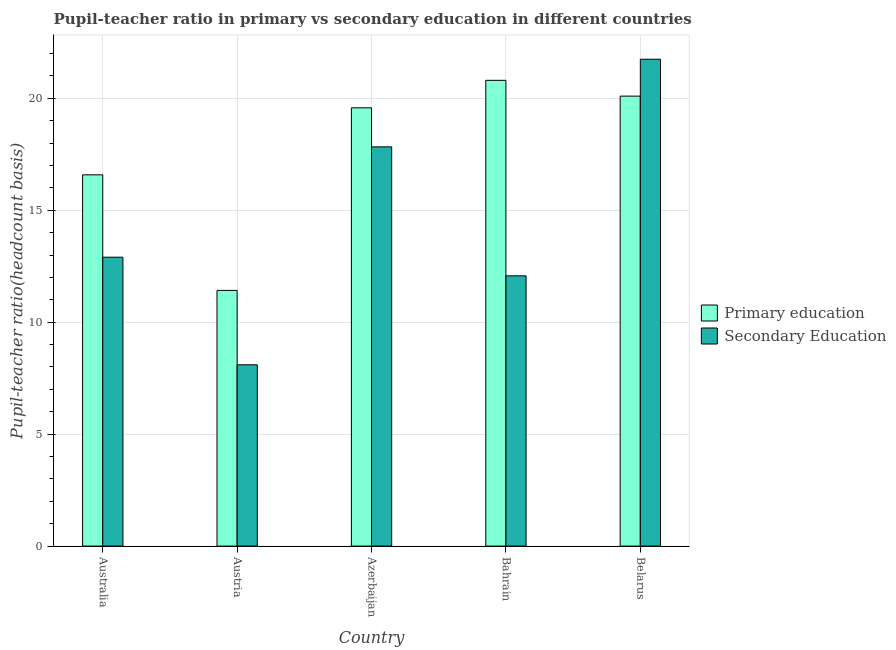Are the number of bars on each tick of the X-axis equal?
Your answer should be compact. Yes. In how many cases, is the number of bars for a given country not equal to the number of legend labels?
Your response must be concise. 0. What is the pupil-teacher ratio in primary education in Australia?
Offer a very short reply. 16.58. Across all countries, what is the maximum pupil teacher ratio on secondary education?
Your answer should be very brief. 21.75. Across all countries, what is the minimum pupil-teacher ratio in primary education?
Offer a terse response. 11.42. In which country was the pupil teacher ratio on secondary education maximum?
Your response must be concise. Belarus. In which country was the pupil-teacher ratio in primary education minimum?
Offer a very short reply. Austria. What is the total pupil teacher ratio on secondary education in the graph?
Make the answer very short. 72.65. What is the difference between the pupil-teacher ratio in primary education in Australia and that in Bahrain?
Your answer should be very brief. -4.22. What is the difference between the pupil teacher ratio on secondary education in Bahrain and the pupil-teacher ratio in primary education in Belarus?
Offer a terse response. -8.03. What is the average pupil-teacher ratio in primary education per country?
Make the answer very short. 17.7. What is the difference between the pupil teacher ratio on secondary education and pupil-teacher ratio in primary education in Azerbaijan?
Give a very brief answer. -1.74. What is the ratio of the pupil-teacher ratio in primary education in Australia to that in Belarus?
Offer a terse response. 0.83. Is the pupil teacher ratio on secondary education in Azerbaijan less than that in Belarus?
Make the answer very short. Yes. What is the difference between the highest and the second highest pupil-teacher ratio in primary education?
Your response must be concise. 0.7. What is the difference between the highest and the lowest pupil-teacher ratio in primary education?
Your answer should be very brief. 9.38. What does the 1st bar from the left in Belarus represents?
Ensure brevity in your answer.  Primary education. How many bars are there?
Provide a succinct answer. 10. Are all the bars in the graph horizontal?
Ensure brevity in your answer.  No. How many countries are there in the graph?
Provide a short and direct response. 5. What is the difference between two consecutive major ticks on the Y-axis?
Ensure brevity in your answer.  5. Does the graph contain grids?
Provide a succinct answer. Yes. How many legend labels are there?
Ensure brevity in your answer.  2. How are the legend labels stacked?
Your answer should be very brief. Vertical. What is the title of the graph?
Make the answer very short. Pupil-teacher ratio in primary vs secondary education in different countries. What is the label or title of the X-axis?
Ensure brevity in your answer.  Country. What is the label or title of the Y-axis?
Ensure brevity in your answer.  Pupil-teacher ratio(headcount basis). What is the Pupil-teacher ratio(headcount basis) of Primary education in Australia?
Ensure brevity in your answer.  16.58. What is the Pupil-teacher ratio(headcount basis) of Secondary Education in Australia?
Your answer should be compact. 12.9. What is the Pupil-teacher ratio(headcount basis) in Primary education in Austria?
Give a very brief answer. 11.42. What is the Pupil-teacher ratio(headcount basis) of Secondary Education in Austria?
Offer a terse response. 8.1. What is the Pupil-teacher ratio(headcount basis) of Primary education in Azerbaijan?
Keep it short and to the point. 19.58. What is the Pupil-teacher ratio(headcount basis) in Secondary Education in Azerbaijan?
Provide a short and direct response. 17.83. What is the Pupil-teacher ratio(headcount basis) in Primary education in Bahrain?
Offer a very short reply. 20.8. What is the Pupil-teacher ratio(headcount basis) of Secondary Education in Bahrain?
Provide a short and direct response. 12.07. What is the Pupil-teacher ratio(headcount basis) of Primary education in Belarus?
Provide a succinct answer. 20.1. What is the Pupil-teacher ratio(headcount basis) in Secondary Education in Belarus?
Provide a short and direct response. 21.75. Across all countries, what is the maximum Pupil-teacher ratio(headcount basis) in Primary education?
Provide a short and direct response. 20.8. Across all countries, what is the maximum Pupil-teacher ratio(headcount basis) of Secondary Education?
Your answer should be very brief. 21.75. Across all countries, what is the minimum Pupil-teacher ratio(headcount basis) of Primary education?
Offer a terse response. 11.42. Across all countries, what is the minimum Pupil-teacher ratio(headcount basis) of Secondary Education?
Your response must be concise. 8.1. What is the total Pupil-teacher ratio(headcount basis) of Primary education in the graph?
Provide a short and direct response. 88.48. What is the total Pupil-teacher ratio(headcount basis) in Secondary Education in the graph?
Give a very brief answer. 72.65. What is the difference between the Pupil-teacher ratio(headcount basis) of Primary education in Australia and that in Austria?
Provide a short and direct response. 5.16. What is the difference between the Pupil-teacher ratio(headcount basis) in Secondary Education in Australia and that in Austria?
Ensure brevity in your answer.  4.8. What is the difference between the Pupil-teacher ratio(headcount basis) in Primary education in Australia and that in Azerbaijan?
Keep it short and to the point. -2.99. What is the difference between the Pupil-teacher ratio(headcount basis) in Secondary Education in Australia and that in Azerbaijan?
Give a very brief answer. -4.93. What is the difference between the Pupil-teacher ratio(headcount basis) of Primary education in Australia and that in Bahrain?
Make the answer very short. -4.22. What is the difference between the Pupil-teacher ratio(headcount basis) of Secondary Education in Australia and that in Bahrain?
Offer a terse response. 0.83. What is the difference between the Pupil-teacher ratio(headcount basis) in Primary education in Australia and that in Belarus?
Provide a succinct answer. -3.52. What is the difference between the Pupil-teacher ratio(headcount basis) of Secondary Education in Australia and that in Belarus?
Your answer should be compact. -8.84. What is the difference between the Pupil-teacher ratio(headcount basis) of Primary education in Austria and that in Azerbaijan?
Your answer should be very brief. -8.16. What is the difference between the Pupil-teacher ratio(headcount basis) in Secondary Education in Austria and that in Azerbaijan?
Make the answer very short. -9.73. What is the difference between the Pupil-teacher ratio(headcount basis) of Primary education in Austria and that in Bahrain?
Your answer should be very brief. -9.38. What is the difference between the Pupil-teacher ratio(headcount basis) of Secondary Education in Austria and that in Bahrain?
Your answer should be very brief. -3.97. What is the difference between the Pupil-teacher ratio(headcount basis) of Primary education in Austria and that in Belarus?
Give a very brief answer. -8.68. What is the difference between the Pupil-teacher ratio(headcount basis) in Secondary Education in Austria and that in Belarus?
Provide a succinct answer. -13.65. What is the difference between the Pupil-teacher ratio(headcount basis) of Primary education in Azerbaijan and that in Bahrain?
Your answer should be very brief. -1.23. What is the difference between the Pupil-teacher ratio(headcount basis) of Secondary Education in Azerbaijan and that in Bahrain?
Ensure brevity in your answer.  5.76. What is the difference between the Pupil-teacher ratio(headcount basis) in Primary education in Azerbaijan and that in Belarus?
Offer a terse response. -0.52. What is the difference between the Pupil-teacher ratio(headcount basis) in Secondary Education in Azerbaijan and that in Belarus?
Offer a very short reply. -3.91. What is the difference between the Pupil-teacher ratio(headcount basis) in Primary education in Bahrain and that in Belarus?
Provide a short and direct response. 0.7. What is the difference between the Pupil-teacher ratio(headcount basis) of Secondary Education in Bahrain and that in Belarus?
Your response must be concise. -9.67. What is the difference between the Pupil-teacher ratio(headcount basis) in Primary education in Australia and the Pupil-teacher ratio(headcount basis) in Secondary Education in Austria?
Offer a very short reply. 8.48. What is the difference between the Pupil-teacher ratio(headcount basis) in Primary education in Australia and the Pupil-teacher ratio(headcount basis) in Secondary Education in Azerbaijan?
Ensure brevity in your answer.  -1.25. What is the difference between the Pupil-teacher ratio(headcount basis) in Primary education in Australia and the Pupil-teacher ratio(headcount basis) in Secondary Education in Bahrain?
Ensure brevity in your answer.  4.51. What is the difference between the Pupil-teacher ratio(headcount basis) of Primary education in Australia and the Pupil-teacher ratio(headcount basis) of Secondary Education in Belarus?
Give a very brief answer. -5.16. What is the difference between the Pupil-teacher ratio(headcount basis) in Primary education in Austria and the Pupil-teacher ratio(headcount basis) in Secondary Education in Azerbaijan?
Make the answer very short. -6.41. What is the difference between the Pupil-teacher ratio(headcount basis) of Primary education in Austria and the Pupil-teacher ratio(headcount basis) of Secondary Education in Bahrain?
Your answer should be very brief. -0.65. What is the difference between the Pupil-teacher ratio(headcount basis) in Primary education in Austria and the Pupil-teacher ratio(headcount basis) in Secondary Education in Belarus?
Your answer should be compact. -10.33. What is the difference between the Pupil-teacher ratio(headcount basis) in Primary education in Azerbaijan and the Pupil-teacher ratio(headcount basis) in Secondary Education in Bahrain?
Offer a very short reply. 7.5. What is the difference between the Pupil-teacher ratio(headcount basis) of Primary education in Azerbaijan and the Pupil-teacher ratio(headcount basis) of Secondary Education in Belarus?
Offer a terse response. -2.17. What is the difference between the Pupil-teacher ratio(headcount basis) in Primary education in Bahrain and the Pupil-teacher ratio(headcount basis) in Secondary Education in Belarus?
Provide a succinct answer. -0.94. What is the average Pupil-teacher ratio(headcount basis) of Primary education per country?
Provide a short and direct response. 17.7. What is the average Pupil-teacher ratio(headcount basis) of Secondary Education per country?
Your response must be concise. 14.53. What is the difference between the Pupil-teacher ratio(headcount basis) in Primary education and Pupil-teacher ratio(headcount basis) in Secondary Education in Australia?
Provide a short and direct response. 3.68. What is the difference between the Pupil-teacher ratio(headcount basis) in Primary education and Pupil-teacher ratio(headcount basis) in Secondary Education in Austria?
Provide a succinct answer. 3.32. What is the difference between the Pupil-teacher ratio(headcount basis) in Primary education and Pupil-teacher ratio(headcount basis) in Secondary Education in Azerbaijan?
Offer a terse response. 1.74. What is the difference between the Pupil-teacher ratio(headcount basis) of Primary education and Pupil-teacher ratio(headcount basis) of Secondary Education in Bahrain?
Offer a terse response. 8.73. What is the difference between the Pupil-teacher ratio(headcount basis) in Primary education and Pupil-teacher ratio(headcount basis) in Secondary Education in Belarus?
Keep it short and to the point. -1.65. What is the ratio of the Pupil-teacher ratio(headcount basis) in Primary education in Australia to that in Austria?
Provide a short and direct response. 1.45. What is the ratio of the Pupil-teacher ratio(headcount basis) in Secondary Education in Australia to that in Austria?
Your response must be concise. 1.59. What is the ratio of the Pupil-teacher ratio(headcount basis) of Primary education in Australia to that in Azerbaijan?
Offer a very short reply. 0.85. What is the ratio of the Pupil-teacher ratio(headcount basis) of Secondary Education in Australia to that in Azerbaijan?
Provide a succinct answer. 0.72. What is the ratio of the Pupil-teacher ratio(headcount basis) in Primary education in Australia to that in Bahrain?
Provide a short and direct response. 0.8. What is the ratio of the Pupil-teacher ratio(headcount basis) in Secondary Education in Australia to that in Bahrain?
Your answer should be very brief. 1.07. What is the ratio of the Pupil-teacher ratio(headcount basis) of Primary education in Australia to that in Belarus?
Provide a succinct answer. 0.83. What is the ratio of the Pupil-teacher ratio(headcount basis) in Secondary Education in Australia to that in Belarus?
Provide a short and direct response. 0.59. What is the ratio of the Pupil-teacher ratio(headcount basis) in Primary education in Austria to that in Azerbaijan?
Provide a short and direct response. 0.58. What is the ratio of the Pupil-teacher ratio(headcount basis) of Secondary Education in Austria to that in Azerbaijan?
Your answer should be compact. 0.45. What is the ratio of the Pupil-teacher ratio(headcount basis) in Primary education in Austria to that in Bahrain?
Offer a very short reply. 0.55. What is the ratio of the Pupil-teacher ratio(headcount basis) in Secondary Education in Austria to that in Bahrain?
Offer a terse response. 0.67. What is the ratio of the Pupil-teacher ratio(headcount basis) of Primary education in Austria to that in Belarus?
Your response must be concise. 0.57. What is the ratio of the Pupil-teacher ratio(headcount basis) in Secondary Education in Austria to that in Belarus?
Keep it short and to the point. 0.37. What is the ratio of the Pupil-teacher ratio(headcount basis) of Primary education in Azerbaijan to that in Bahrain?
Your answer should be very brief. 0.94. What is the ratio of the Pupil-teacher ratio(headcount basis) in Secondary Education in Azerbaijan to that in Bahrain?
Offer a very short reply. 1.48. What is the ratio of the Pupil-teacher ratio(headcount basis) in Primary education in Azerbaijan to that in Belarus?
Your answer should be compact. 0.97. What is the ratio of the Pupil-teacher ratio(headcount basis) in Secondary Education in Azerbaijan to that in Belarus?
Provide a succinct answer. 0.82. What is the ratio of the Pupil-teacher ratio(headcount basis) of Primary education in Bahrain to that in Belarus?
Your answer should be compact. 1.04. What is the ratio of the Pupil-teacher ratio(headcount basis) in Secondary Education in Bahrain to that in Belarus?
Give a very brief answer. 0.56. What is the difference between the highest and the second highest Pupil-teacher ratio(headcount basis) in Primary education?
Keep it short and to the point. 0.7. What is the difference between the highest and the second highest Pupil-teacher ratio(headcount basis) of Secondary Education?
Give a very brief answer. 3.91. What is the difference between the highest and the lowest Pupil-teacher ratio(headcount basis) of Primary education?
Make the answer very short. 9.38. What is the difference between the highest and the lowest Pupil-teacher ratio(headcount basis) in Secondary Education?
Your answer should be compact. 13.65. 